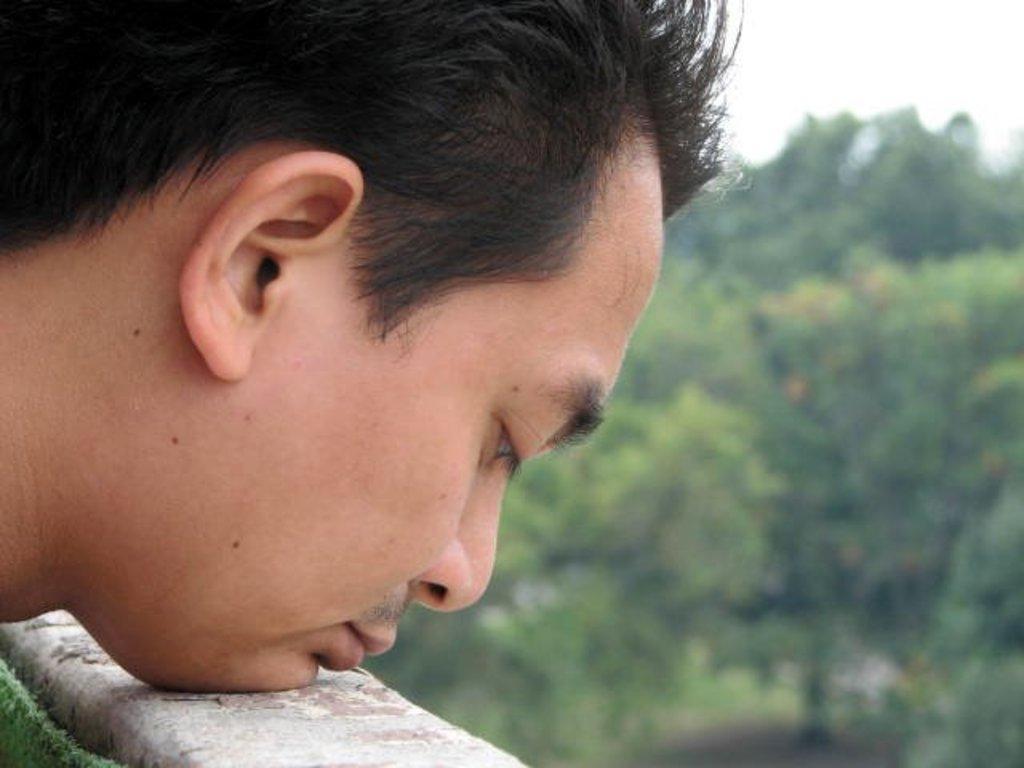Can you describe this image briefly? In this image we can see a man's face kept on a wall. In the background it is blur. 